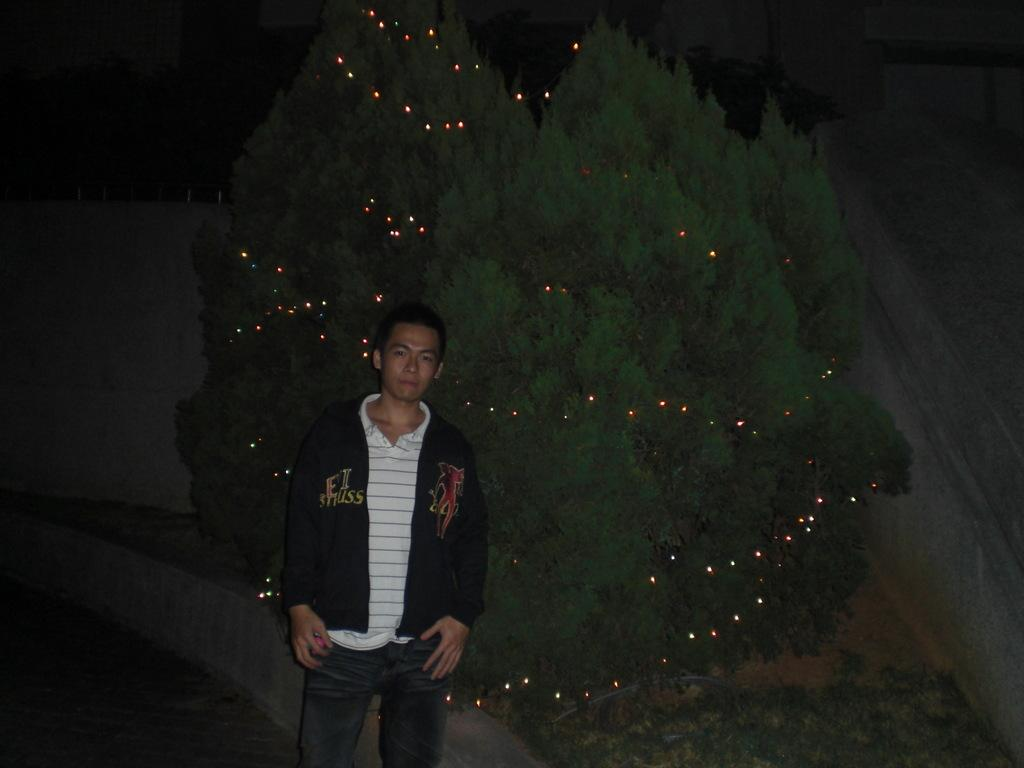What is the main subject of the image? There is a man standing in the image. Where is the man standing? The man is standing on the ground. What type of vegetation can be seen in the image? There are plants and a tree with decorative lights in the image. What other structures are present in the image? There is a wall in the image. What type of gold ornaments is the man wearing in the image? There is no mention of gold ornaments in the image, and the man is not wearing any visible jewelry. 